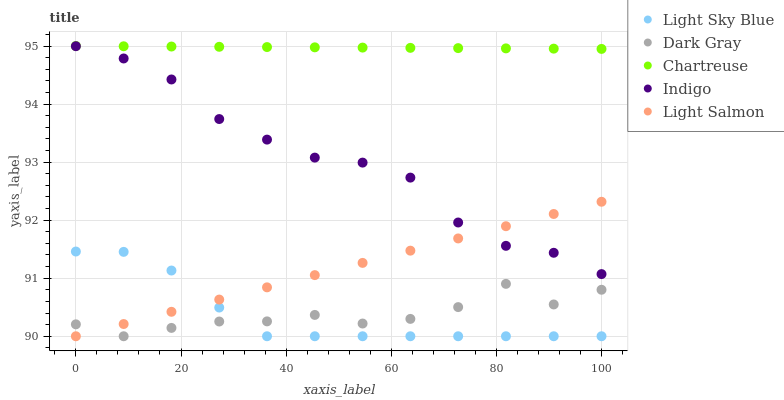Does Light Sky Blue have the minimum area under the curve?
Answer yes or no. Yes. Does Chartreuse have the maximum area under the curve?
Answer yes or no. Yes. Does Chartreuse have the minimum area under the curve?
Answer yes or no. No. Does Light Sky Blue have the maximum area under the curve?
Answer yes or no. No. Is Light Salmon the smoothest?
Answer yes or no. Yes. Is Dark Gray the roughest?
Answer yes or no. Yes. Is Chartreuse the smoothest?
Answer yes or no. No. Is Chartreuse the roughest?
Answer yes or no. No. Does Dark Gray have the lowest value?
Answer yes or no. Yes. Does Chartreuse have the lowest value?
Answer yes or no. No. Does Chartreuse have the highest value?
Answer yes or no. Yes. Does Light Sky Blue have the highest value?
Answer yes or no. No. Is Light Sky Blue less than Chartreuse?
Answer yes or no. Yes. Is Chartreuse greater than Indigo?
Answer yes or no. Yes. Does Indigo intersect Light Salmon?
Answer yes or no. Yes. Is Indigo less than Light Salmon?
Answer yes or no. No. Is Indigo greater than Light Salmon?
Answer yes or no. No. Does Light Sky Blue intersect Chartreuse?
Answer yes or no. No. 